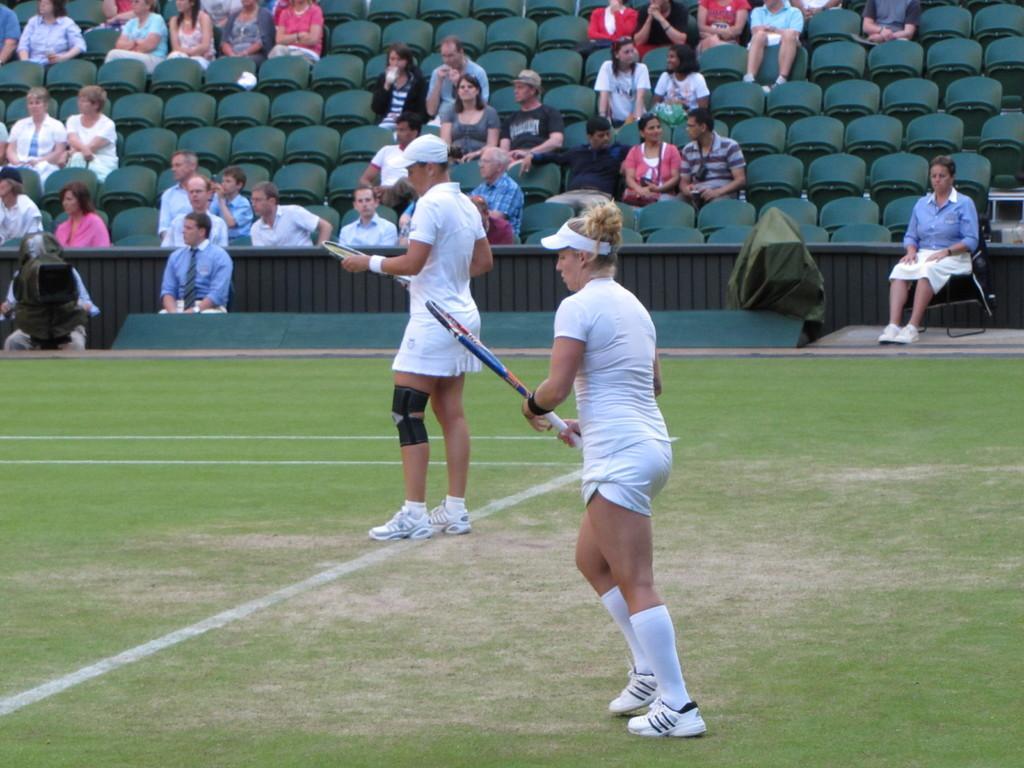Describe this image in one or two sentences. In this picture we can see two persons are standing in the ground and they are holding bat, in the left side of the given image a person is holding a camera, and other people are seated on the chairs and they are watching the game. 